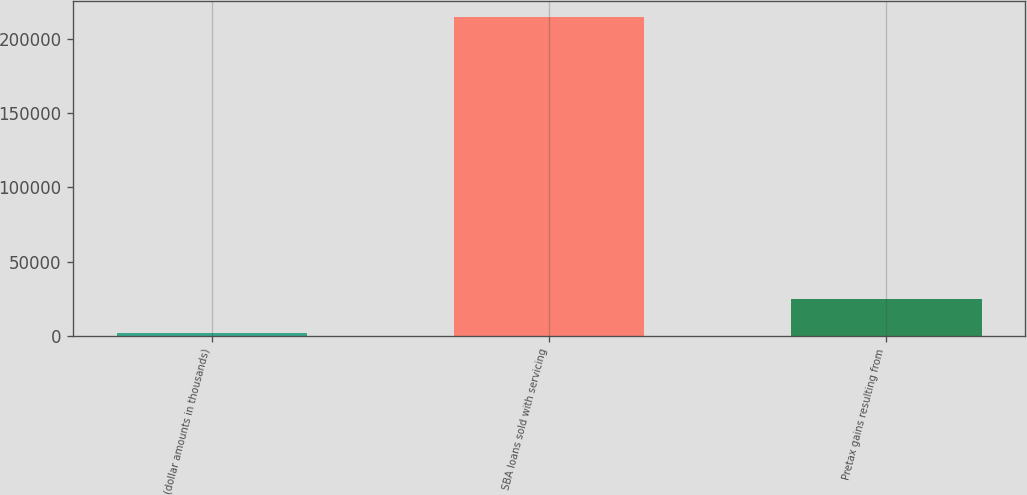Convert chart. <chart><loc_0><loc_0><loc_500><loc_500><bar_chart><fcel>(dollar amounts in thousands)<fcel>SBA loans sold with servicing<fcel>Pretax gains resulting from<nl><fcel>2014<fcel>214760<fcel>24579<nl></chart> 